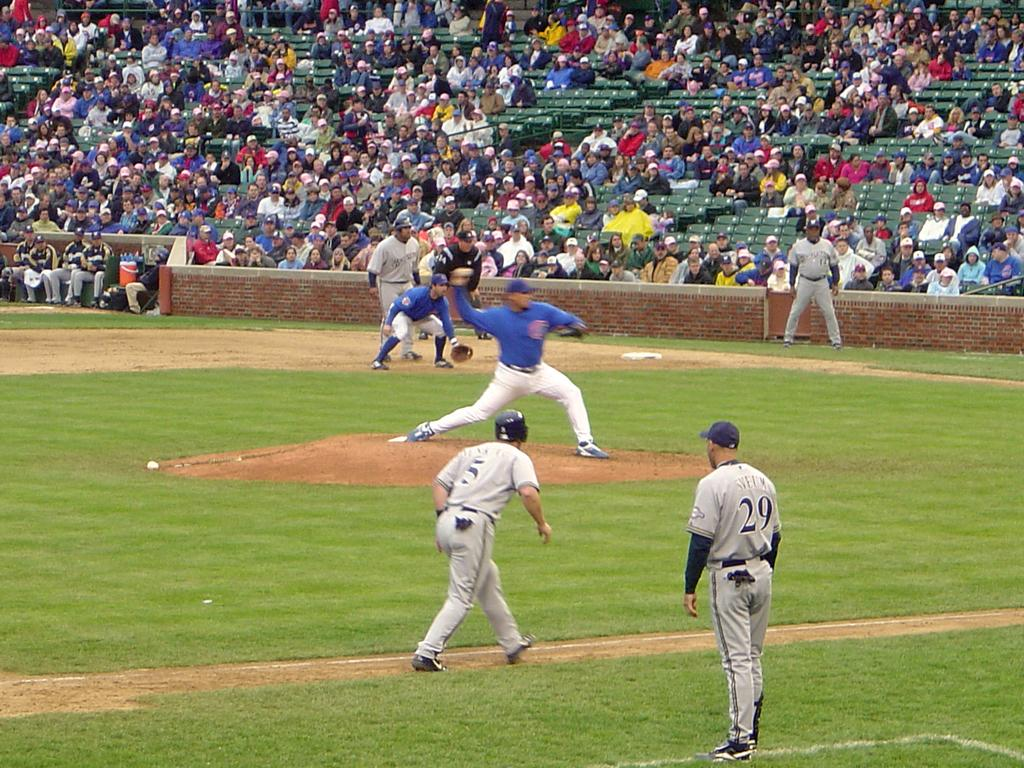<image>
Present a compact description of the photo's key features. Player number 5 tries to steal a base while the other team in blue pitches the baseball. 